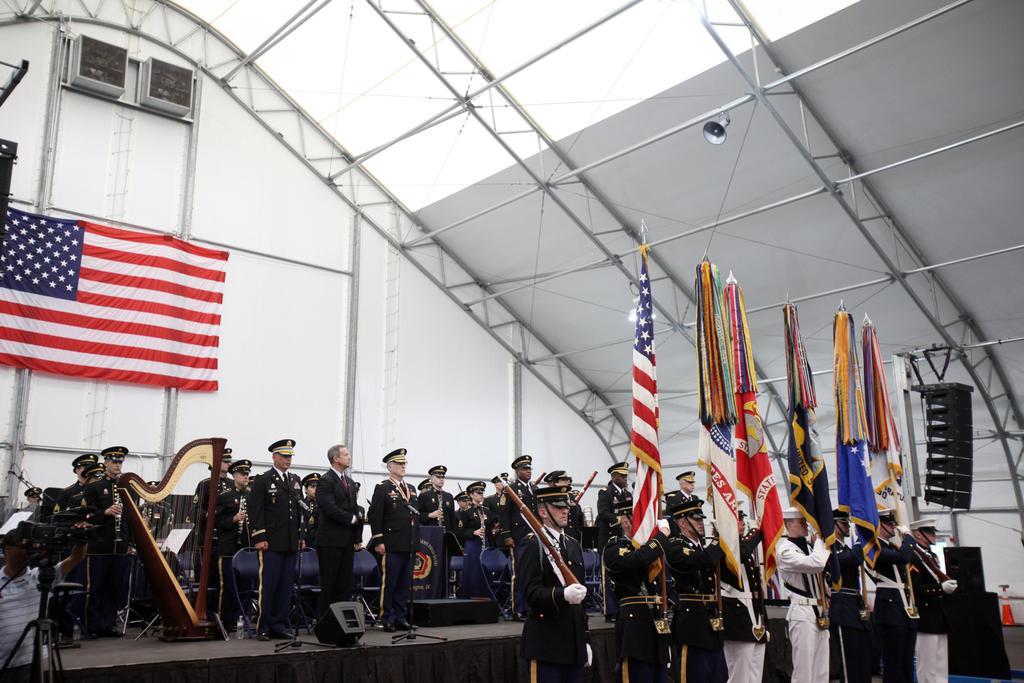Could you give a brief overview of what you see in this image? In this picture, we see many people are standing on the stage. On the left side, we see a man in the uniform is playing the musical instrument. Behind them, we see a white wall on which a flag in red, white and blue color are placed. At the bottom of the picture, we see people in uniform are holding guns and flags in their hands. These flags are in different colors. This picture might be clicked in the auditorium. 